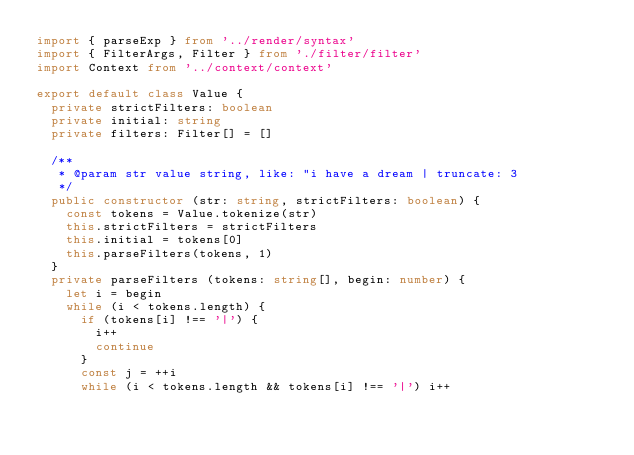Convert code to text. <code><loc_0><loc_0><loc_500><loc_500><_TypeScript_>import { parseExp } from '../render/syntax'
import { FilterArgs, Filter } from './filter/filter'
import Context from '../context/context'

export default class Value {
  private strictFilters: boolean
  private initial: string
  private filters: Filter[] = []

  /**
   * @param str value string, like: "i have a dream | truncate: 3
   */
  public constructor (str: string, strictFilters: boolean) {
    const tokens = Value.tokenize(str)
    this.strictFilters = strictFilters
    this.initial = tokens[0]
    this.parseFilters(tokens, 1)
  }
  private parseFilters (tokens: string[], begin: number) {
    let i = begin
    while (i < tokens.length) {
      if (tokens[i] !== '|') {
        i++
        continue
      }
      const j = ++i
      while (i < tokens.length && tokens[i] !== '|') i++</code> 